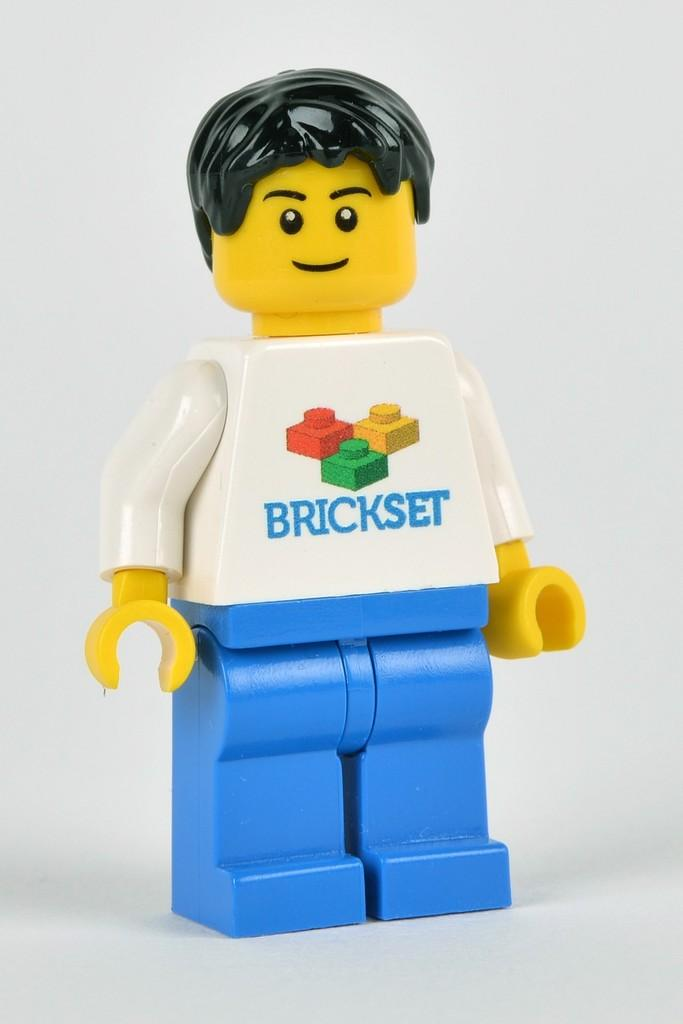What is the main subject of the image? The main subject of the image is a mini mannequin. What is featured on the mini mannequin? There is text on the mini mannequin. What is the color of the background in the image? The background of the image is white. Can you tell me how many people are swinging in the background of the image? There are no people or swings present in the image. What type of medical procedure is being performed on the mini mannequin in the image? There is no indication of any medical procedures or hospital settings in the image. What is the digestion process of the mini mannequin in the image? The mini mannequin is an inanimate object and does not have a digestion process. 